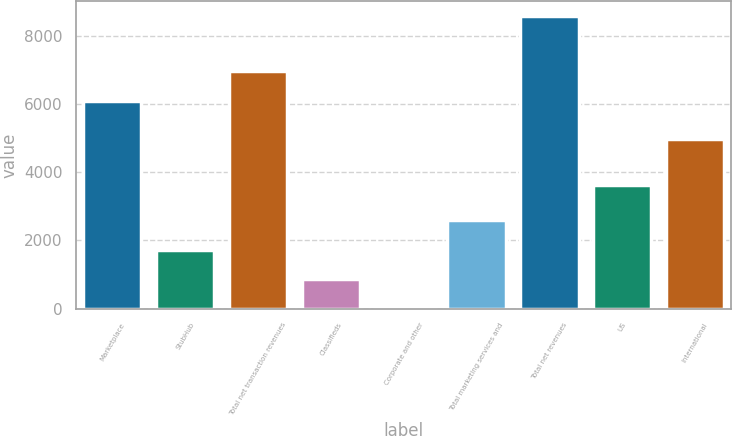Convert chart. <chart><loc_0><loc_0><loc_500><loc_500><bar_chart><fcel>Marketplace<fcel>StubHub<fcel>Total net transaction revenues<fcel>Classifieds<fcel>Corporate and other<fcel>Total marketing services and<fcel>Total net revenues<fcel>US<fcel>International<nl><fcel>6103<fcel>1732<fcel>6960.5<fcel>874.5<fcel>17<fcel>2589.5<fcel>8592<fcel>3624<fcel>4968<nl></chart> 